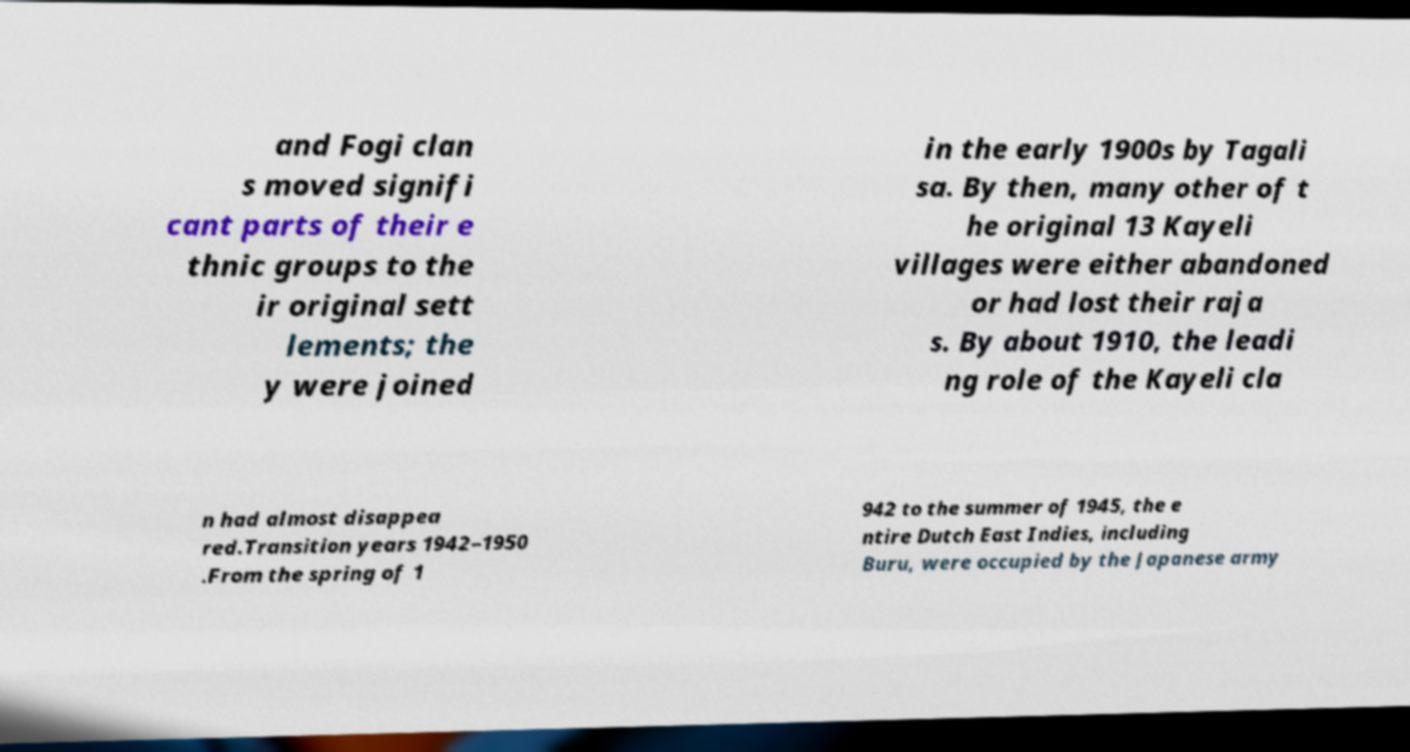Can you accurately transcribe the text from the provided image for me? and Fogi clan s moved signifi cant parts of their e thnic groups to the ir original sett lements; the y were joined in the early 1900s by Tagali sa. By then, many other of t he original 13 Kayeli villages were either abandoned or had lost their raja s. By about 1910, the leadi ng role of the Kayeli cla n had almost disappea red.Transition years 1942–1950 .From the spring of 1 942 to the summer of 1945, the e ntire Dutch East Indies, including Buru, were occupied by the Japanese army 